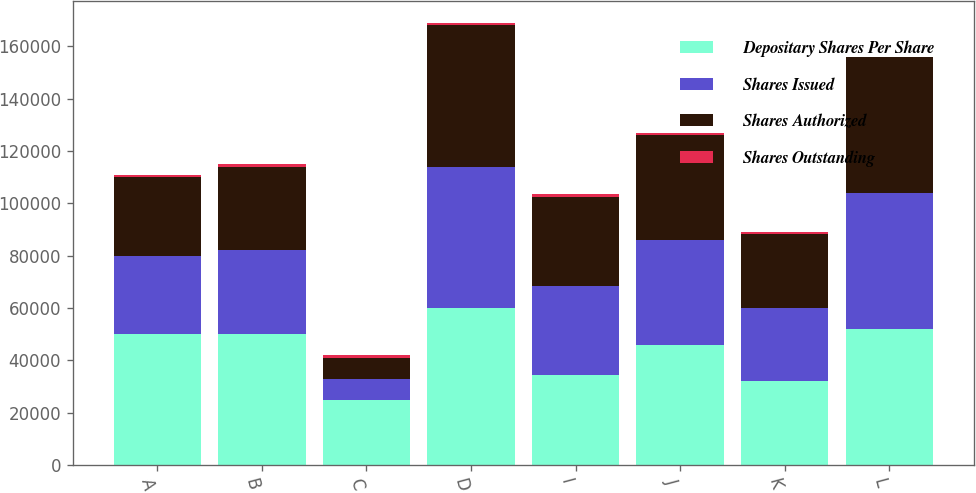Convert chart to OTSL. <chart><loc_0><loc_0><loc_500><loc_500><stacked_bar_chart><ecel><fcel>A<fcel>B<fcel>C<fcel>D<fcel>I<fcel>J<fcel>K<fcel>L<nl><fcel>Depositary Shares Per Share<fcel>50000<fcel>50000<fcel>25000<fcel>60000<fcel>34500<fcel>46000<fcel>32200<fcel>52000<nl><fcel>Shares Issued<fcel>30000<fcel>32000<fcel>8000<fcel>54000<fcel>34000<fcel>40000<fcel>28000<fcel>52000<nl><fcel>Shares Authorized<fcel>29999<fcel>32000<fcel>8000<fcel>53999<fcel>34000<fcel>40000<fcel>28000<fcel>52000<nl><fcel>Shares Outstanding<fcel>1000<fcel>1000<fcel>1000<fcel>1000<fcel>1000<fcel>1000<fcel>1000<fcel>25<nl></chart> 